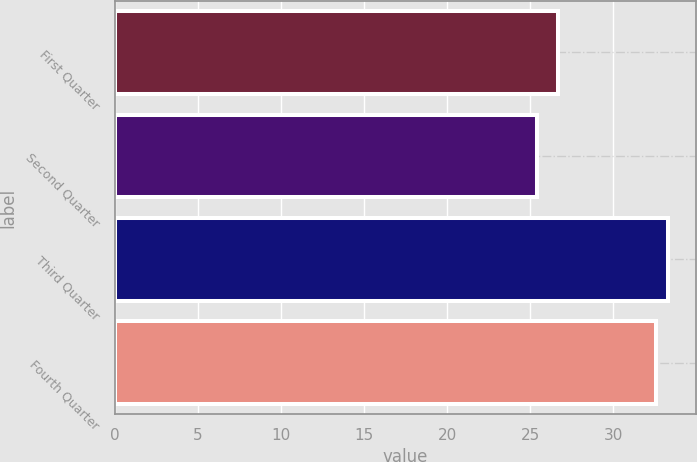Convert chart. <chart><loc_0><loc_0><loc_500><loc_500><bar_chart><fcel>First Quarter<fcel>Second Quarter<fcel>Third Quarter<fcel>Fourth Quarter<nl><fcel>26.65<fcel>25.43<fcel>33.31<fcel>32.56<nl></chart> 